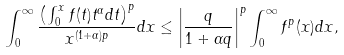<formula> <loc_0><loc_0><loc_500><loc_500>\int ^ { \infty } _ { 0 } \frac { \left ( \int ^ { x } _ { 0 } f ( t ) t ^ { \alpha } d t \right ) ^ { p } } { x ^ { ( 1 + \alpha ) p } } d x \leq \left | \frac { q } { 1 + \alpha q } \right | ^ { p } \int ^ { \infty } _ { 0 } f ^ { p } ( x ) d x ,</formula> 